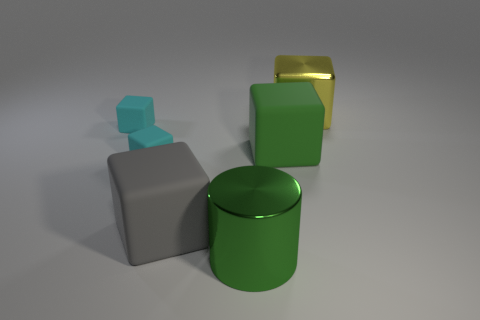Subtract 2 blocks. How many blocks are left? 3 Subtract all big gray rubber blocks. How many blocks are left? 4 Subtract all yellow cubes. How many cubes are left? 4 Subtract all blue blocks. Subtract all purple cylinders. How many blocks are left? 5 Add 2 large blocks. How many objects exist? 8 Subtract all cylinders. How many objects are left? 5 Subtract all green rubber cubes. Subtract all big yellow things. How many objects are left? 4 Add 6 matte blocks. How many matte blocks are left? 10 Add 3 large purple cubes. How many large purple cubes exist? 3 Subtract 1 green cylinders. How many objects are left? 5 